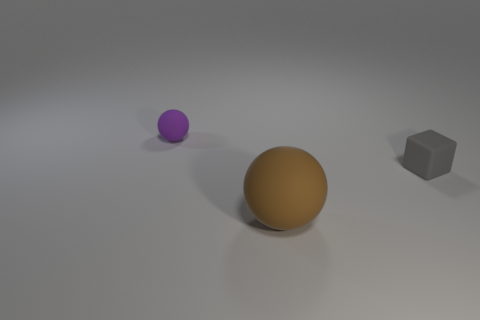Add 3 big balls. How many objects exist? 6 Subtract all cubes. How many objects are left? 2 Add 1 large matte objects. How many large matte objects are left? 2 Add 1 small gray rubber objects. How many small gray rubber objects exist? 2 Subtract 0 blue spheres. How many objects are left? 3 Subtract all large things. Subtract all large brown matte balls. How many objects are left? 1 